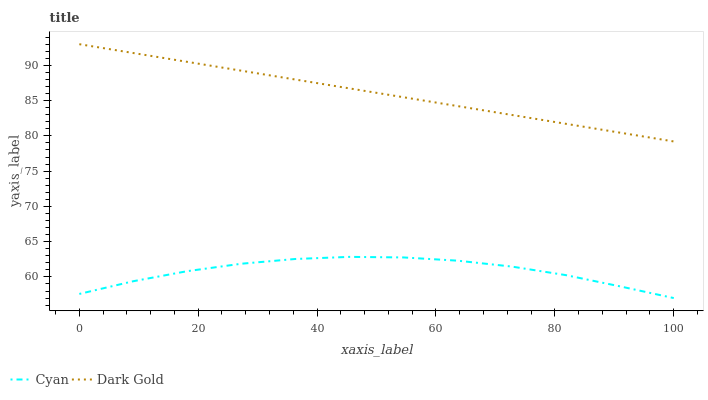Does Cyan have the minimum area under the curve?
Answer yes or no. Yes. Does Dark Gold have the maximum area under the curve?
Answer yes or no. Yes. Does Dark Gold have the minimum area under the curve?
Answer yes or no. No. Is Dark Gold the smoothest?
Answer yes or no. Yes. Is Cyan the roughest?
Answer yes or no. Yes. Is Dark Gold the roughest?
Answer yes or no. No. Does Cyan have the lowest value?
Answer yes or no. Yes. Does Dark Gold have the lowest value?
Answer yes or no. No. Does Dark Gold have the highest value?
Answer yes or no. Yes. Is Cyan less than Dark Gold?
Answer yes or no. Yes. Is Dark Gold greater than Cyan?
Answer yes or no. Yes. Does Cyan intersect Dark Gold?
Answer yes or no. No. 